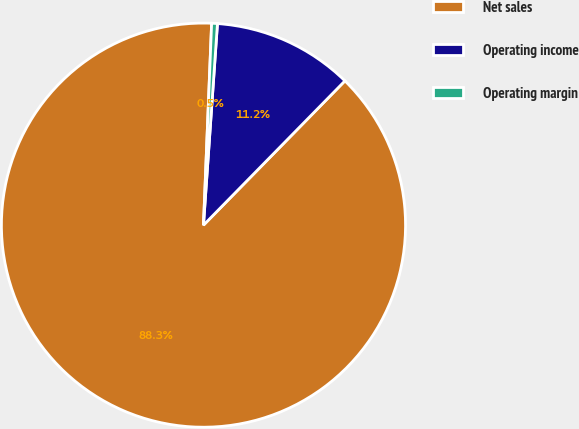Convert chart. <chart><loc_0><loc_0><loc_500><loc_500><pie_chart><fcel>Net sales<fcel>Operating income<fcel>Operating margin<nl><fcel>88.3%<fcel>11.24%<fcel>0.46%<nl></chart> 